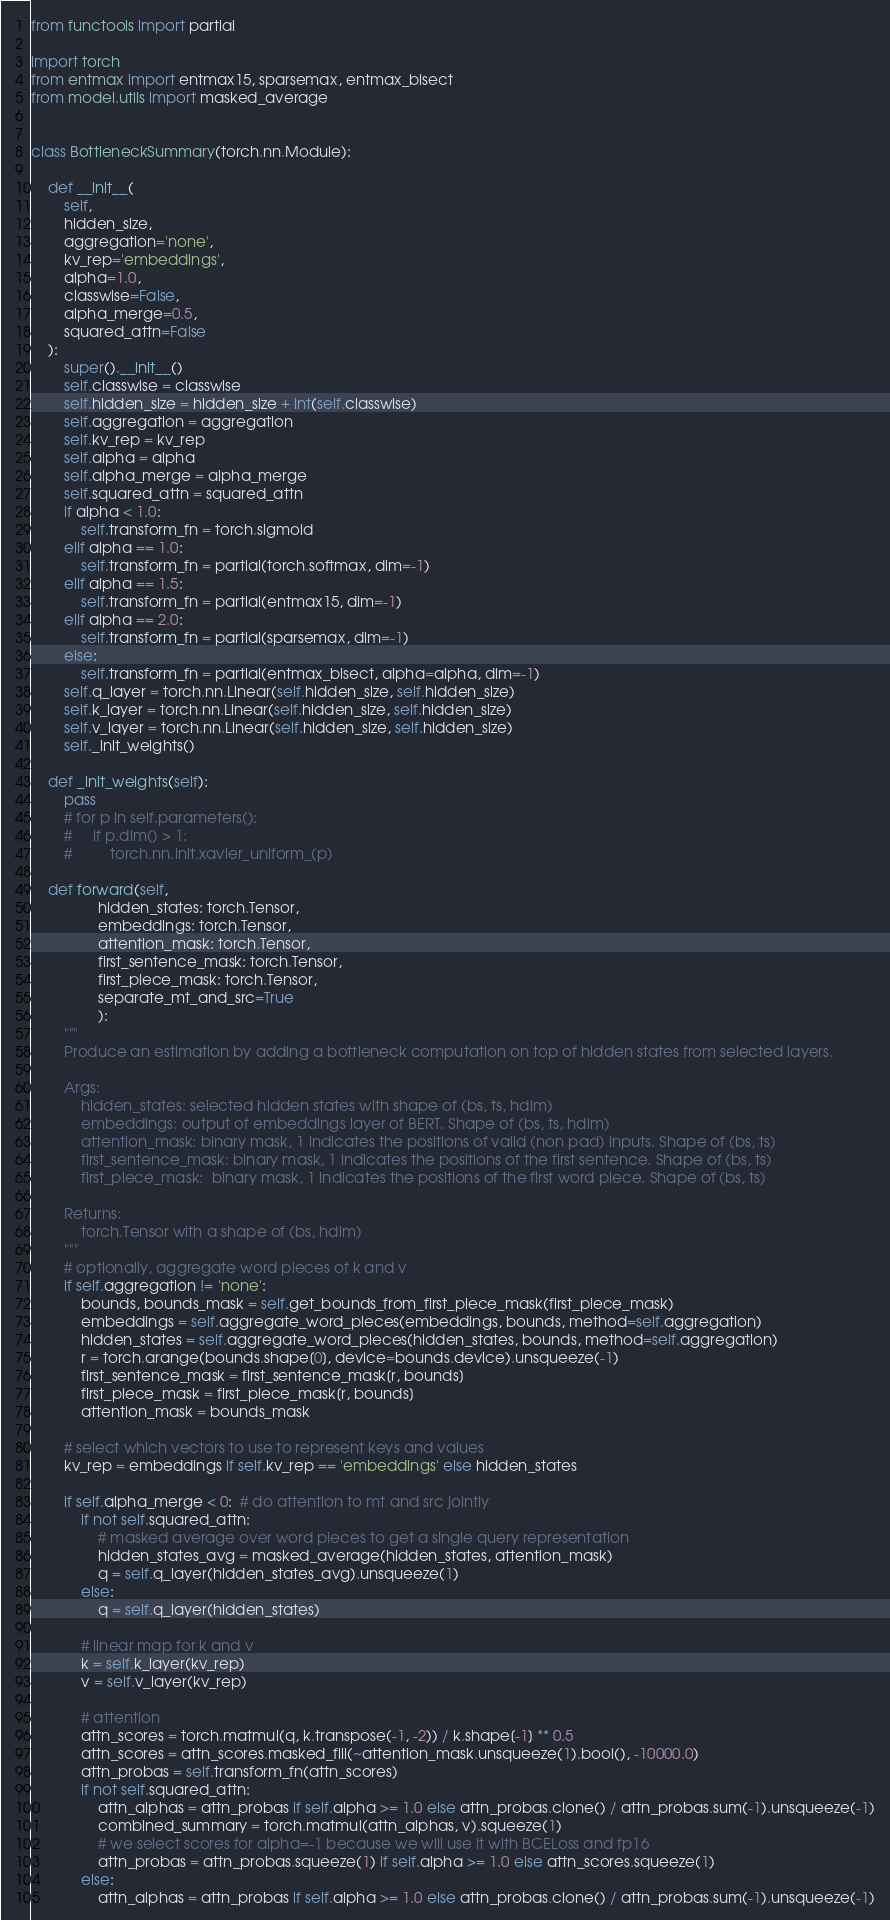Convert code to text. <code><loc_0><loc_0><loc_500><loc_500><_Python_>from functools import partial

import torch
from entmax import entmax15, sparsemax, entmax_bisect
from model.utils import masked_average


class BottleneckSummary(torch.nn.Module):

    def __init__(
        self,
        hidden_size,
        aggregation='none',
        kv_rep='embeddings',
        alpha=1.0,
        classwise=False,
        alpha_merge=0.5,
        squared_attn=False
    ):
        super().__init__()
        self.classwise = classwise
        self.hidden_size = hidden_size + int(self.classwise)
        self.aggregation = aggregation
        self.kv_rep = kv_rep
        self.alpha = alpha
        self.alpha_merge = alpha_merge
        self.squared_attn = squared_attn
        if alpha < 1.0:
            self.transform_fn = torch.sigmoid
        elif alpha == 1.0:
            self.transform_fn = partial(torch.softmax, dim=-1)
        elif alpha == 1.5:
            self.transform_fn = partial(entmax15, dim=-1)
        elif alpha == 2.0:
            self.transform_fn = partial(sparsemax, dim=-1)
        else:
            self.transform_fn = partial(entmax_bisect, alpha=alpha, dim=-1)
        self.q_layer = torch.nn.Linear(self.hidden_size, self.hidden_size)
        self.k_layer = torch.nn.Linear(self.hidden_size, self.hidden_size)
        self.v_layer = torch.nn.Linear(self.hidden_size, self.hidden_size)
        self._init_weights()

    def _init_weights(self):
        pass
        # for p in self.parameters():
        #     if p.dim() > 1:
        #         torch.nn.init.xavier_uniform_(p)

    def forward(self,
                hidden_states: torch.Tensor,
                embeddings: torch.Tensor,
                attention_mask: torch.Tensor,
                first_sentence_mask: torch.Tensor,
                first_piece_mask: torch.Tensor,
                separate_mt_and_src=True
                ):
        """
        Produce an estimation by adding a bottleneck computation on top of hidden states from selected layers.

        Args:
            hidden_states: selected hidden states with shape of (bs, ts, hdim)
            embeddings: output of embeddings layer of BERT. Shape of (bs, ts, hdim)
            attention_mask: binary mask, 1 indicates the positions of valid (non pad) inputs. Shape of (bs, ts)
            first_sentence_mask: binary mask, 1 indicates the positions of the first sentence. Shape of (bs, ts)
            first_piece_mask:  binary mask, 1 indicates the positions of the first word piece. Shape of (bs, ts)

        Returns:
            torch.Tensor with a shape of (bs, hdim)
        """
        # optionally, aggregate word pieces of k and v
        if self.aggregation != 'none':
            bounds, bounds_mask = self.get_bounds_from_first_piece_mask(first_piece_mask)
            embeddings = self.aggregate_word_pieces(embeddings, bounds, method=self.aggregation)
            hidden_states = self.aggregate_word_pieces(hidden_states, bounds, method=self.aggregation)
            r = torch.arange(bounds.shape[0], device=bounds.device).unsqueeze(-1)
            first_sentence_mask = first_sentence_mask[r, bounds]
            first_piece_mask = first_piece_mask[r, bounds]
            attention_mask = bounds_mask

        # select which vectors to use to represent keys and values
        kv_rep = embeddings if self.kv_rep == 'embeddings' else hidden_states

        if self.alpha_merge < 0:  # do attention to mt and src jointly
            if not self.squared_attn:
                # masked average over word pieces to get a single query representation
                hidden_states_avg = masked_average(hidden_states, attention_mask)
                q = self.q_layer(hidden_states_avg).unsqueeze(1)
            else:
                q = self.q_layer(hidden_states)

            # linear map for k and v
            k = self.k_layer(kv_rep)
            v = self.v_layer(kv_rep)

            # attention
            attn_scores = torch.matmul(q, k.transpose(-1, -2)) / k.shape[-1] ** 0.5
            attn_scores = attn_scores.masked_fill(~attention_mask.unsqueeze(1).bool(), -10000.0)
            attn_probas = self.transform_fn(attn_scores)
            if not self.squared_attn:
                attn_alphas = attn_probas if self.alpha >= 1.0 else attn_probas.clone() / attn_probas.sum(-1).unsqueeze(-1)
                combined_summary = torch.matmul(attn_alphas, v).squeeze(1)
                # we select scores for alpha=-1 because we will use it with BCELoss and fp16
                attn_probas = attn_probas.squeeze(1) if self.alpha >= 1.0 else attn_scores.squeeze(1)
            else:
                attn_alphas = attn_probas if self.alpha >= 1.0 else attn_probas.clone() / attn_probas.sum(-1).unsqueeze(-1)</code> 